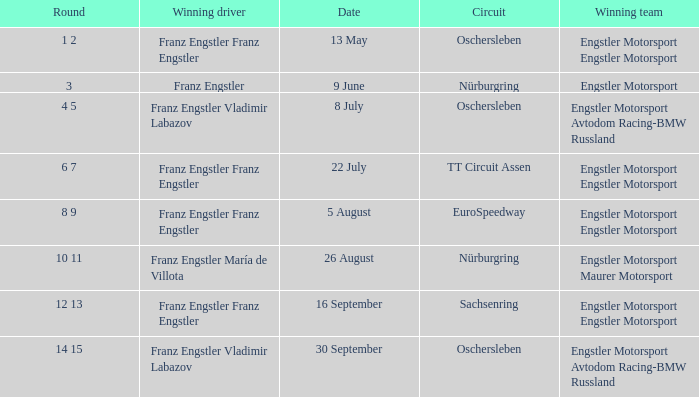What Round was the Winning Team Engstler Motorsport Maurer Motorsport? 10 11. 